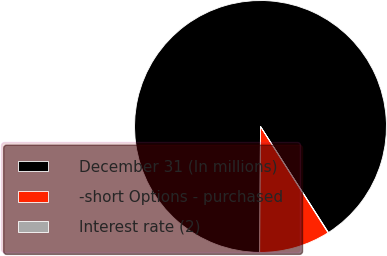Convert chart to OTSL. <chart><loc_0><loc_0><loc_500><loc_500><pie_chart><fcel>December 31 (In millions)<fcel>-short Options - purchased<fcel>Interest rate (2)<nl><fcel>90.83%<fcel>9.12%<fcel>0.05%<nl></chart> 